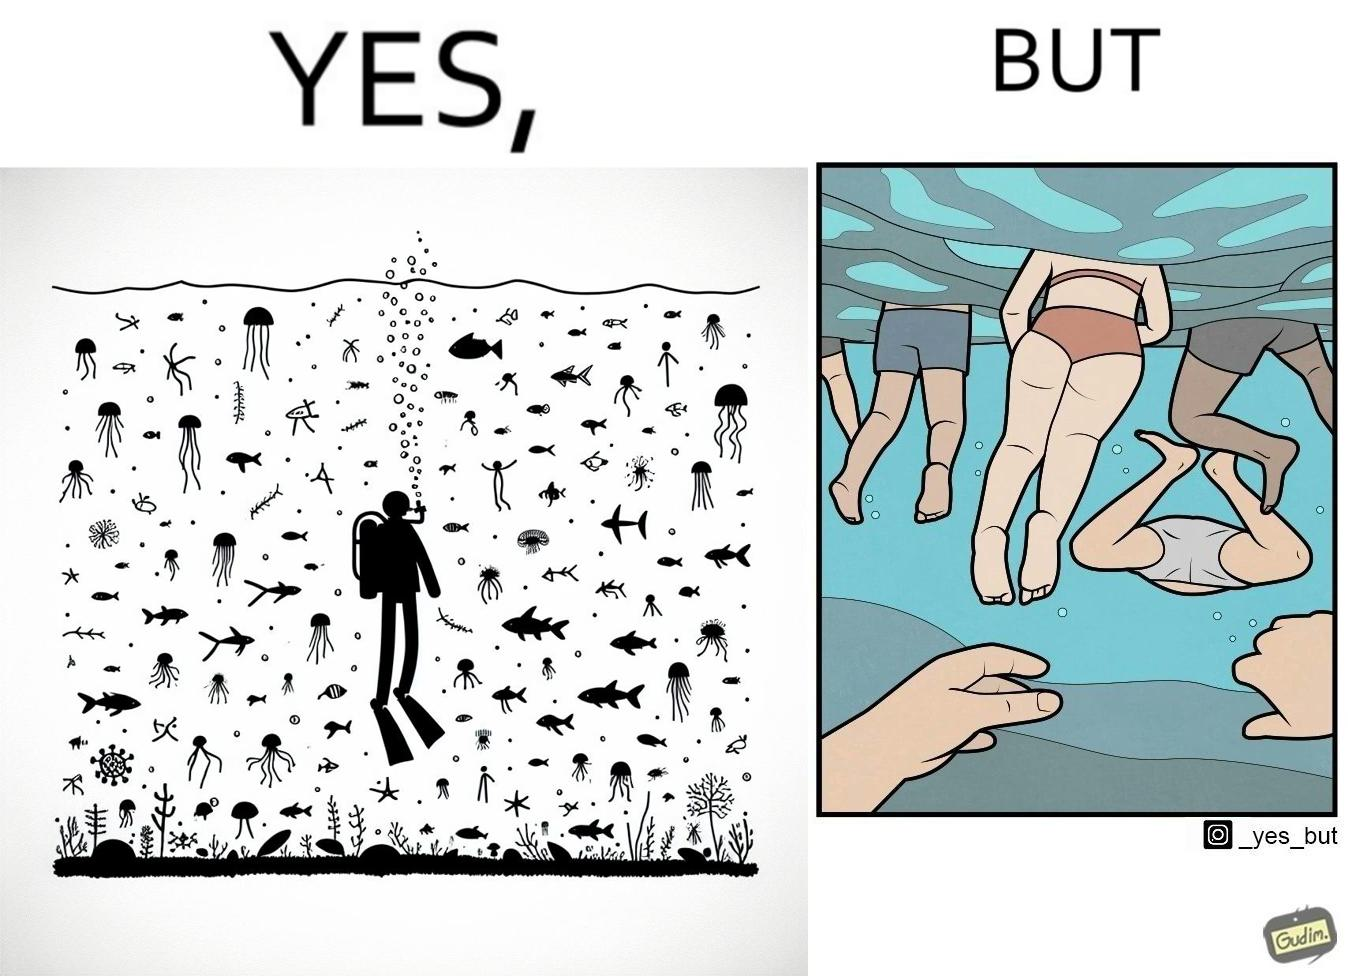Is there satirical content in this image? Yes, this image is satirical. 